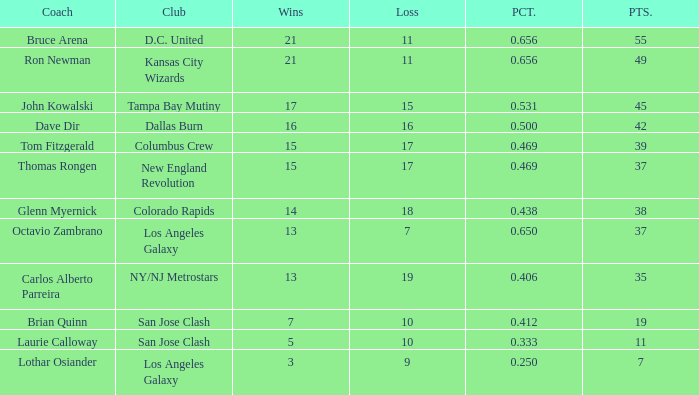Calculate the sum of points for bruce arena when he has 21 successful games. 55.0. 